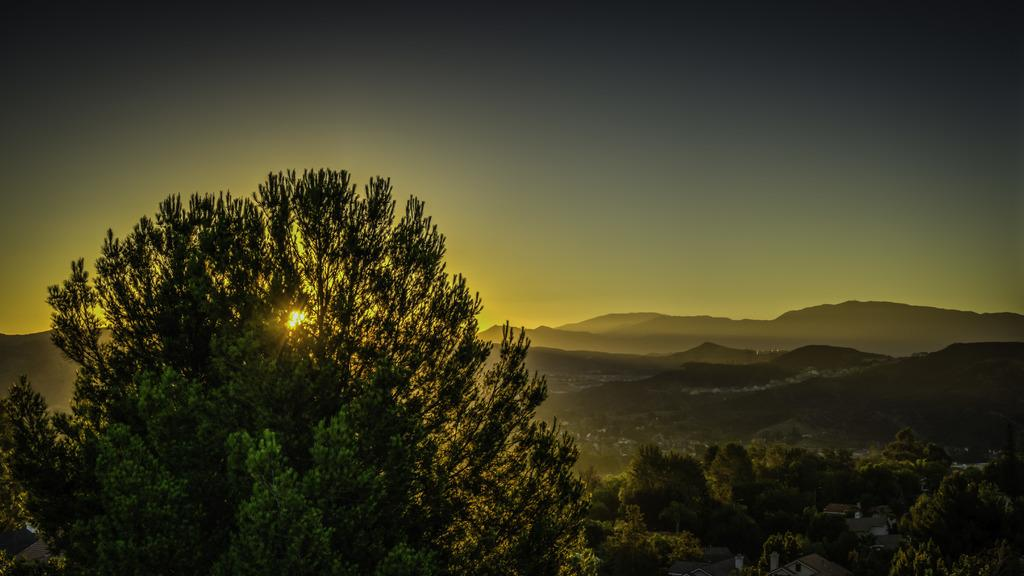What type of vegetation can be seen in the image? There are trees in the image. What geographical features are present in the image? There are hills in the image. What is visible in the background of the image? The sky is visible in the background of the image. How many fish can be seen swimming in the image? There are no fish present in the image; it features trees and hills with a visible sky in the background. What is the chance of finding a shop in the image? There is no mention of a shop in the image, so it is impossible to determine the chance of finding one. 